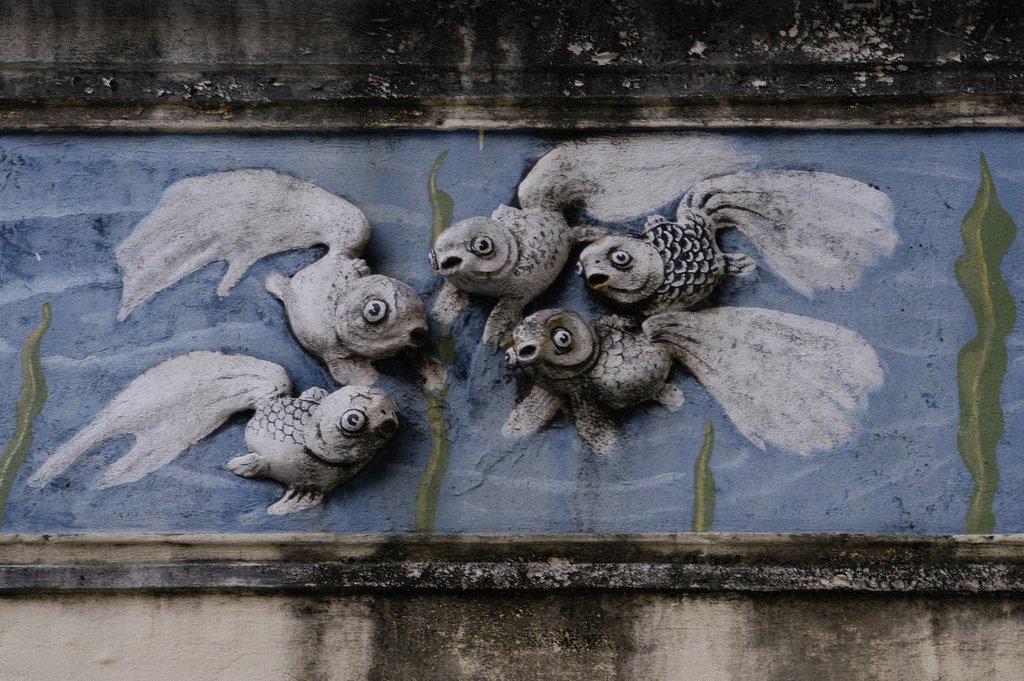Describe this image in one or two sentences. In this image, we can see some sculptures on the wall. 